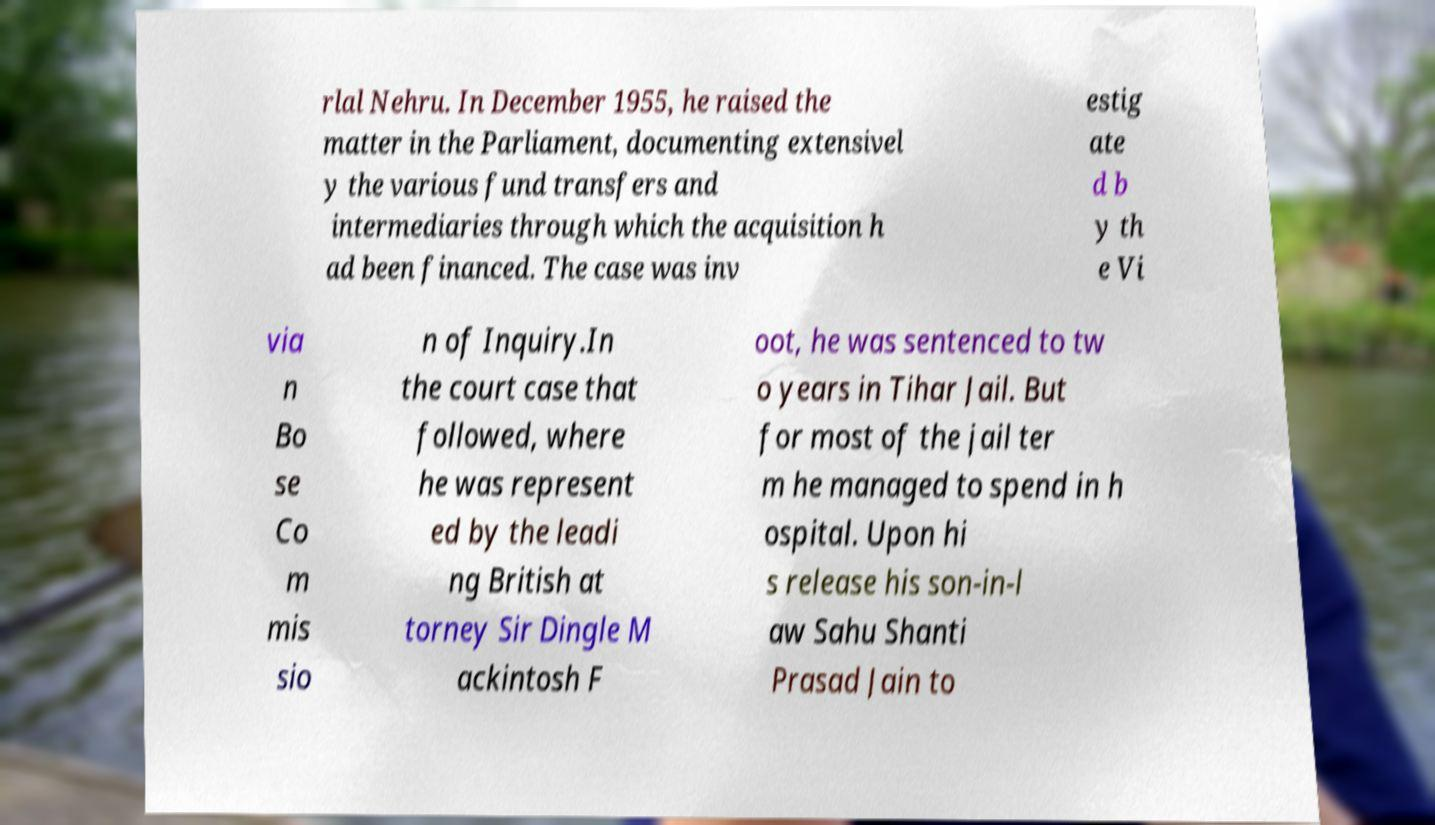What messages or text are displayed in this image? I need them in a readable, typed format. rlal Nehru. In December 1955, he raised the matter in the Parliament, documenting extensivel y the various fund transfers and intermediaries through which the acquisition h ad been financed. The case was inv estig ate d b y th e Vi via n Bo se Co m mis sio n of Inquiry.In the court case that followed, where he was represent ed by the leadi ng British at torney Sir Dingle M ackintosh F oot, he was sentenced to tw o years in Tihar Jail. But for most of the jail ter m he managed to spend in h ospital. Upon hi s release his son-in-l aw Sahu Shanti Prasad Jain to 